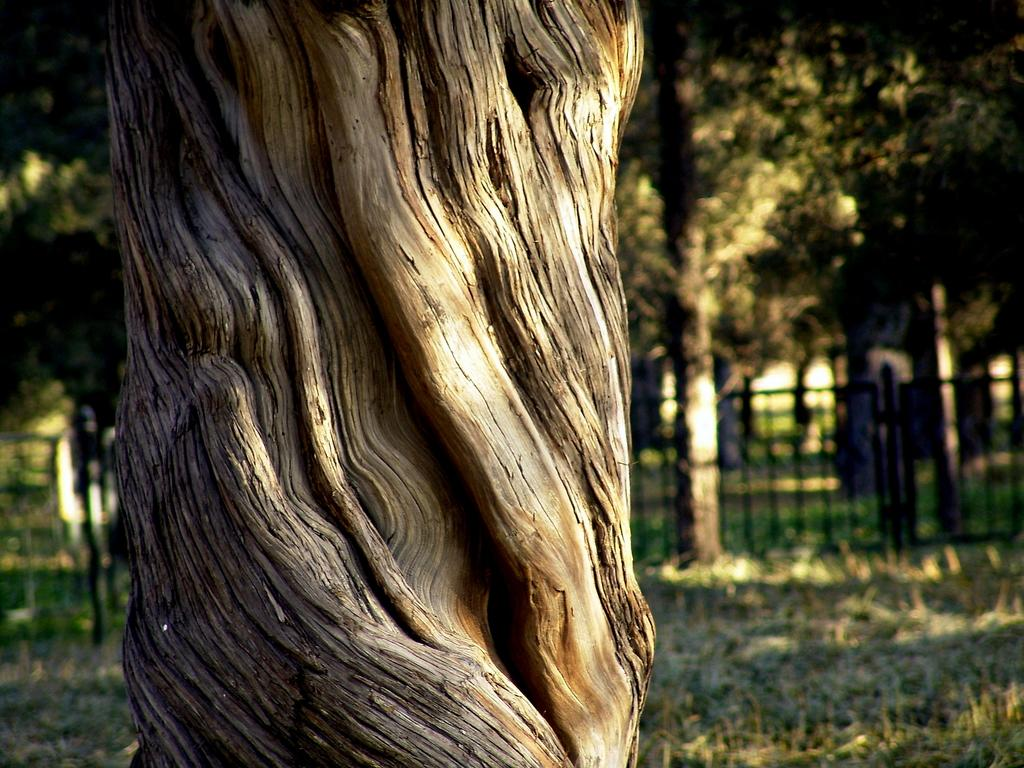What object is the main focus of the image? There is a trunk in the image. What can be seen in the background of the image? There is a railing and many trees in the background of the image. What type of vegetation is visible on the ground at the bottom of the image? Grass is visible on the ground at the bottom of the image. What type of tax is being discussed in the image? There is no discussion of tax in the image; it features a trunk, railing, trees, and grass. How does the clover move around in the image? There is no clover present in the image, so it cannot move around. 